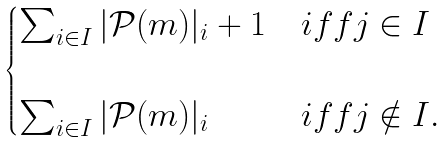Convert formula to latex. <formula><loc_0><loc_0><loc_500><loc_500>\begin{cases} \sum _ { i \in I } | \mathcal { P } ( m ) | _ { i } + 1 & i f f j \in I \\ & \\ \sum _ { i \in I } | \mathcal { P } ( m ) | _ { i } & i f f j \notin I . \end{cases}</formula> 